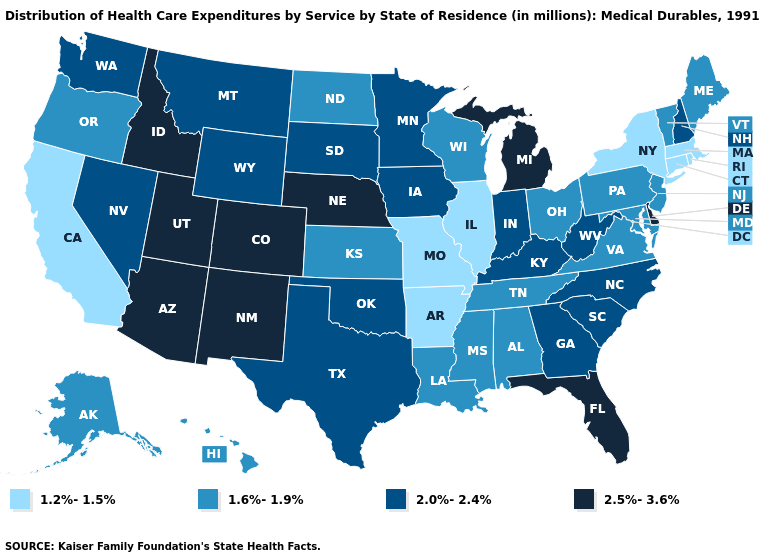Name the states that have a value in the range 1.6%-1.9%?
Concise answer only. Alabama, Alaska, Hawaii, Kansas, Louisiana, Maine, Maryland, Mississippi, New Jersey, North Dakota, Ohio, Oregon, Pennsylvania, Tennessee, Vermont, Virginia, Wisconsin. Does West Virginia have a lower value than Michigan?
Answer briefly. Yes. How many symbols are there in the legend?
Give a very brief answer. 4. What is the value of Kentucky?
Concise answer only. 2.0%-2.4%. What is the value of South Carolina?
Answer briefly. 2.0%-2.4%. Name the states that have a value in the range 2.0%-2.4%?
Be succinct. Georgia, Indiana, Iowa, Kentucky, Minnesota, Montana, Nevada, New Hampshire, North Carolina, Oklahoma, South Carolina, South Dakota, Texas, Washington, West Virginia, Wyoming. What is the value of Missouri?
Concise answer only. 1.2%-1.5%. Name the states that have a value in the range 2.0%-2.4%?
Keep it brief. Georgia, Indiana, Iowa, Kentucky, Minnesota, Montana, Nevada, New Hampshire, North Carolina, Oklahoma, South Carolina, South Dakota, Texas, Washington, West Virginia, Wyoming. What is the value of Hawaii?
Answer briefly. 1.6%-1.9%. Does Arkansas have the same value as West Virginia?
Quick response, please. No. Name the states that have a value in the range 1.2%-1.5%?
Give a very brief answer. Arkansas, California, Connecticut, Illinois, Massachusetts, Missouri, New York, Rhode Island. Does New Jersey have the same value as Missouri?
Short answer required. No. Name the states that have a value in the range 2.5%-3.6%?
Short answer required. Arizona, Colorado, Delaware, Florida, Idaho, Michigan, Nebraska, New Mexico, Utah. What is the highest value in the USA?
Write a very short answer. 2.5%-3.6%. Name the states that have a value in the range 2.0%-2.4%?
Quick response, please. Georgia, Indiana, Iowa, Kentucky, Minnesota, Montana, Nevada, New Hampshire, North Carolina, Oklahoma, South Carolina, South Dakota, Texas, Washington, West Virginia, Wyoming. 